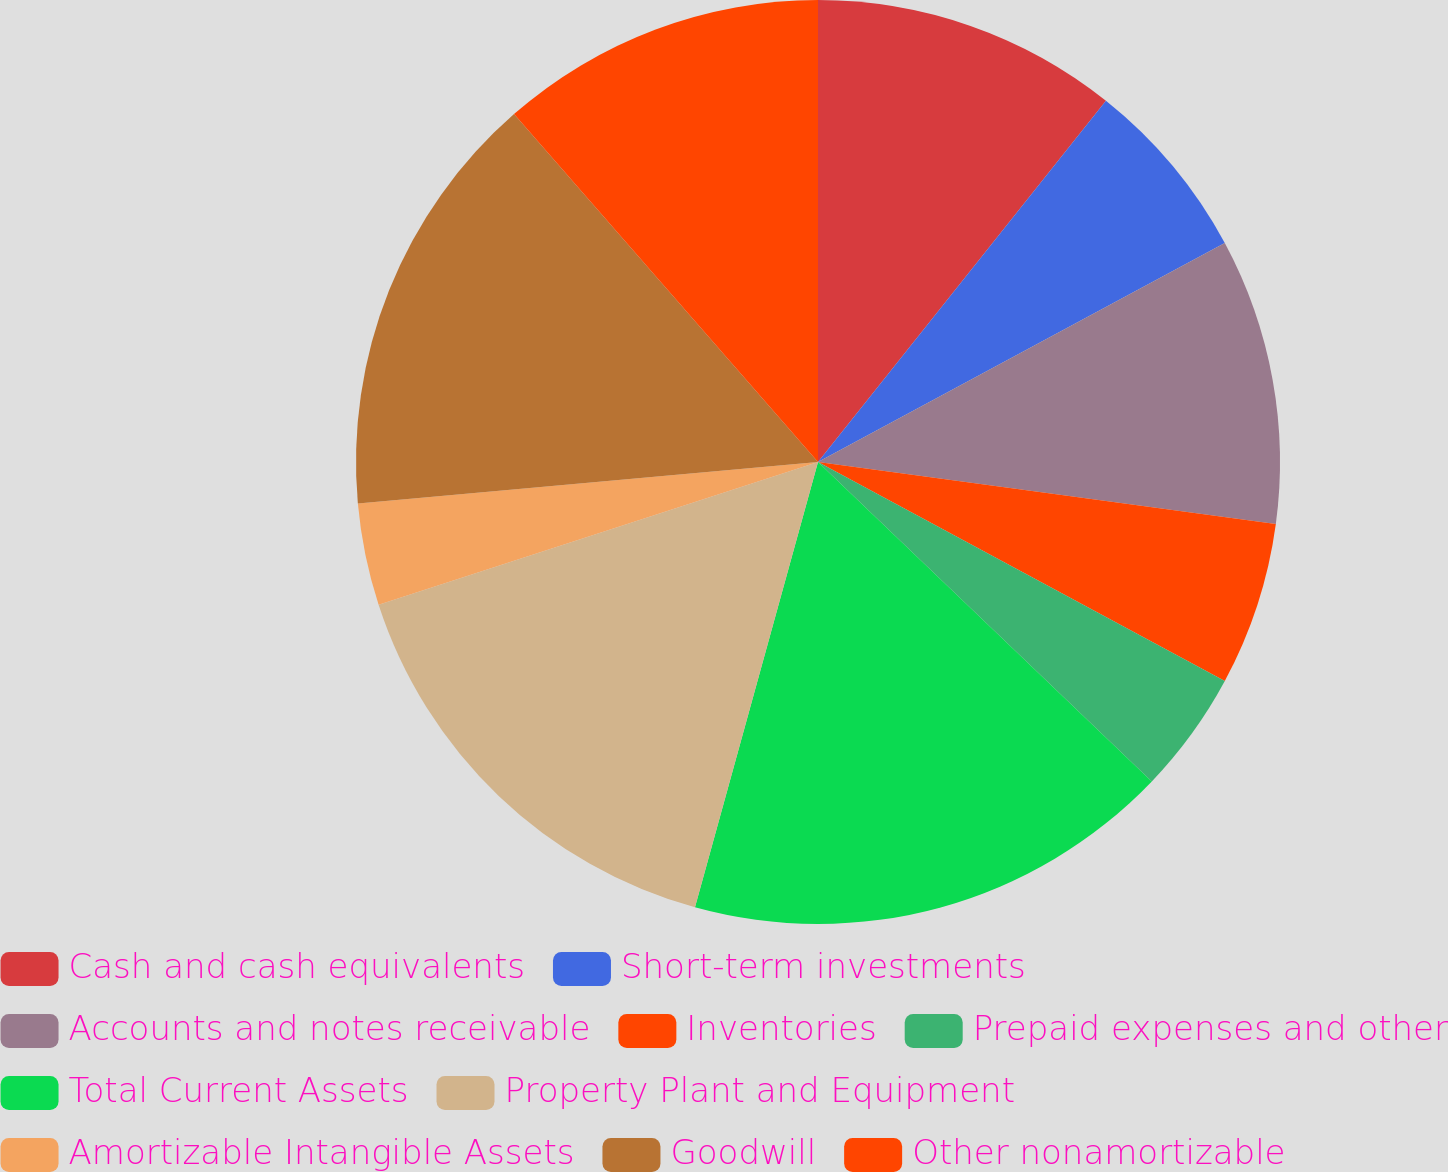Convert chart to OTSL. <chart><loc_0><loc_0><loc_500><loc_500><pie_chart><fcel>Cash and cash equivalents<fcel>Short-term investments<fcel>Accounts and notes receivable<fcel>Inventories<fcel>Prepaid expenses and other<fcel>Total Current Assets<fcel>Property Plant and Equipment<fcel>Amortizable Intangible Assets<fcel>Goodwill<fcel>Other nonamortizable<nl><fcel>10.71%<fcel>6.43%<fcel>10.0%<fcel>5.72%<fcel>4.29%<fcel>17.14%<fcel>15.71%<fcel>3.57%<fcel>15.0%<fcel>11.43%<nl></chart> 